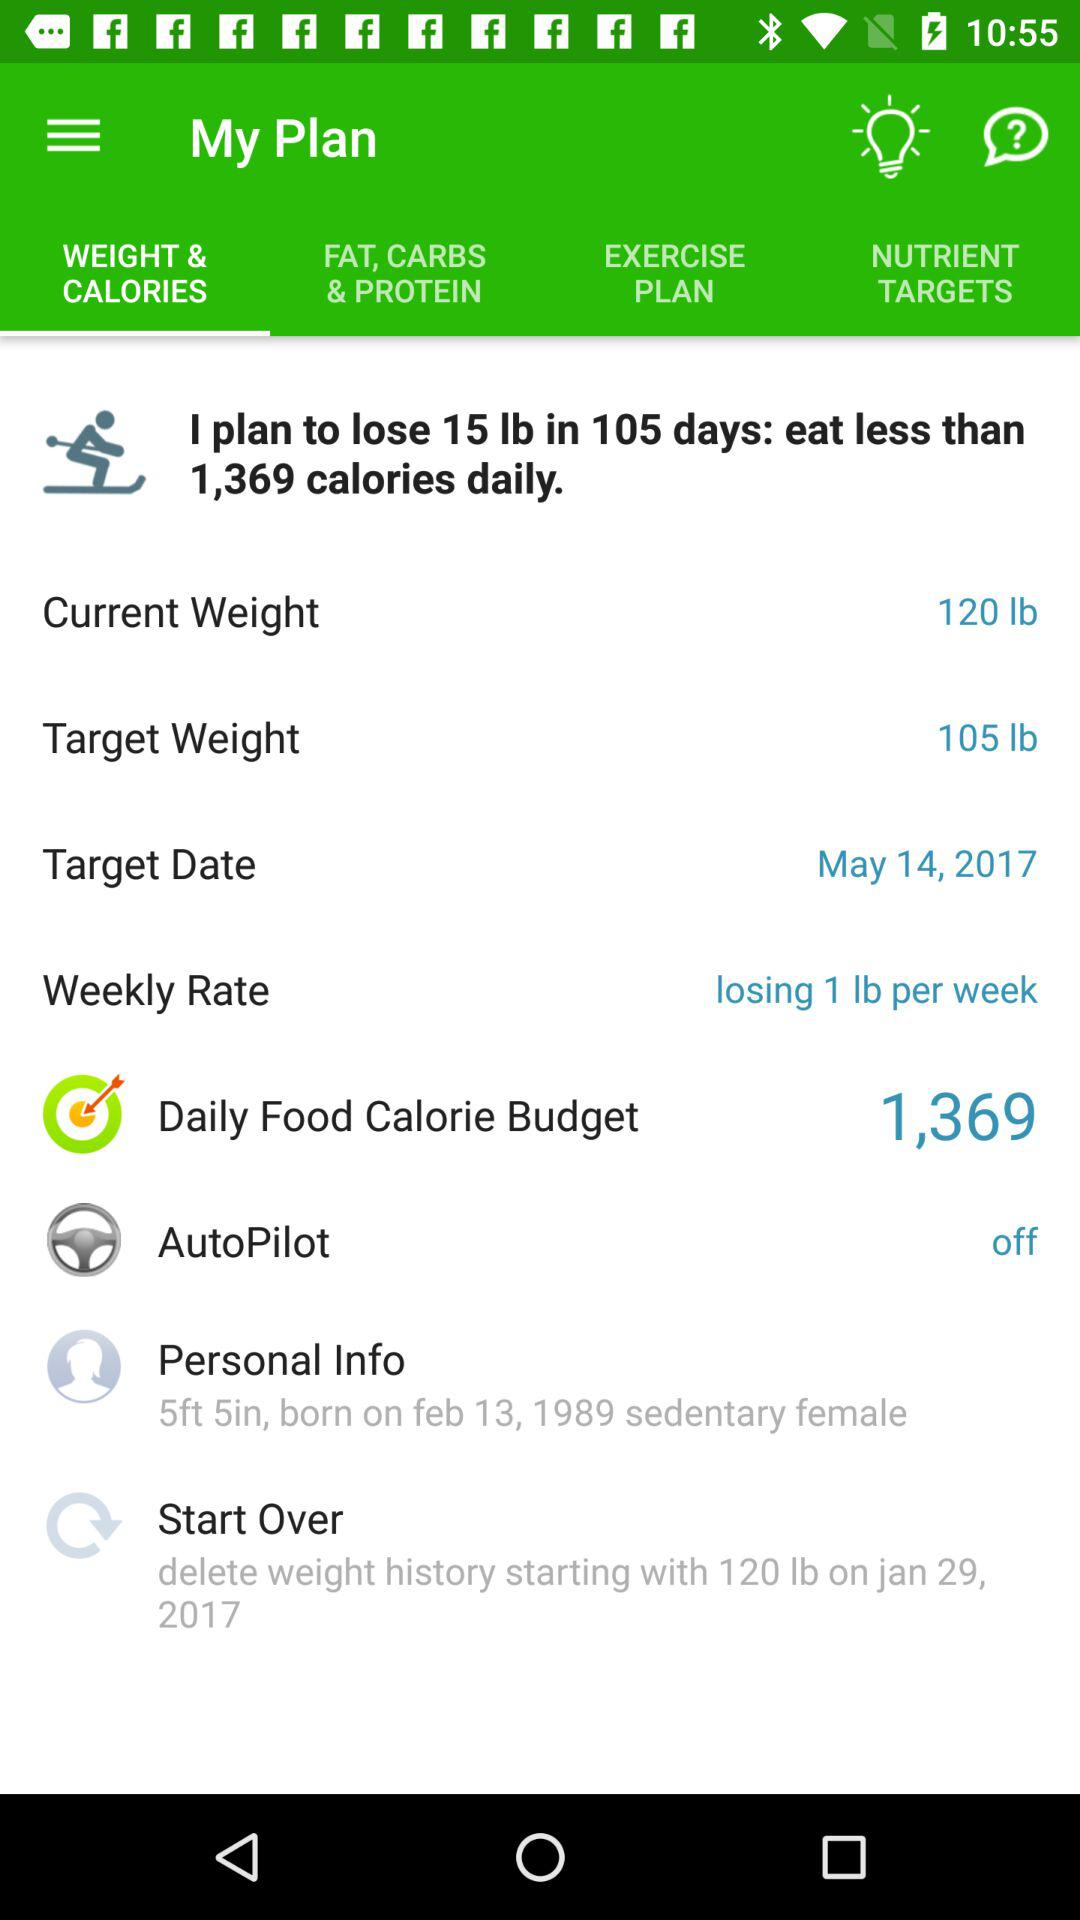When did the diet plan start over?
When the provided information is insufficient, respond with <no answer>. <no answer> 